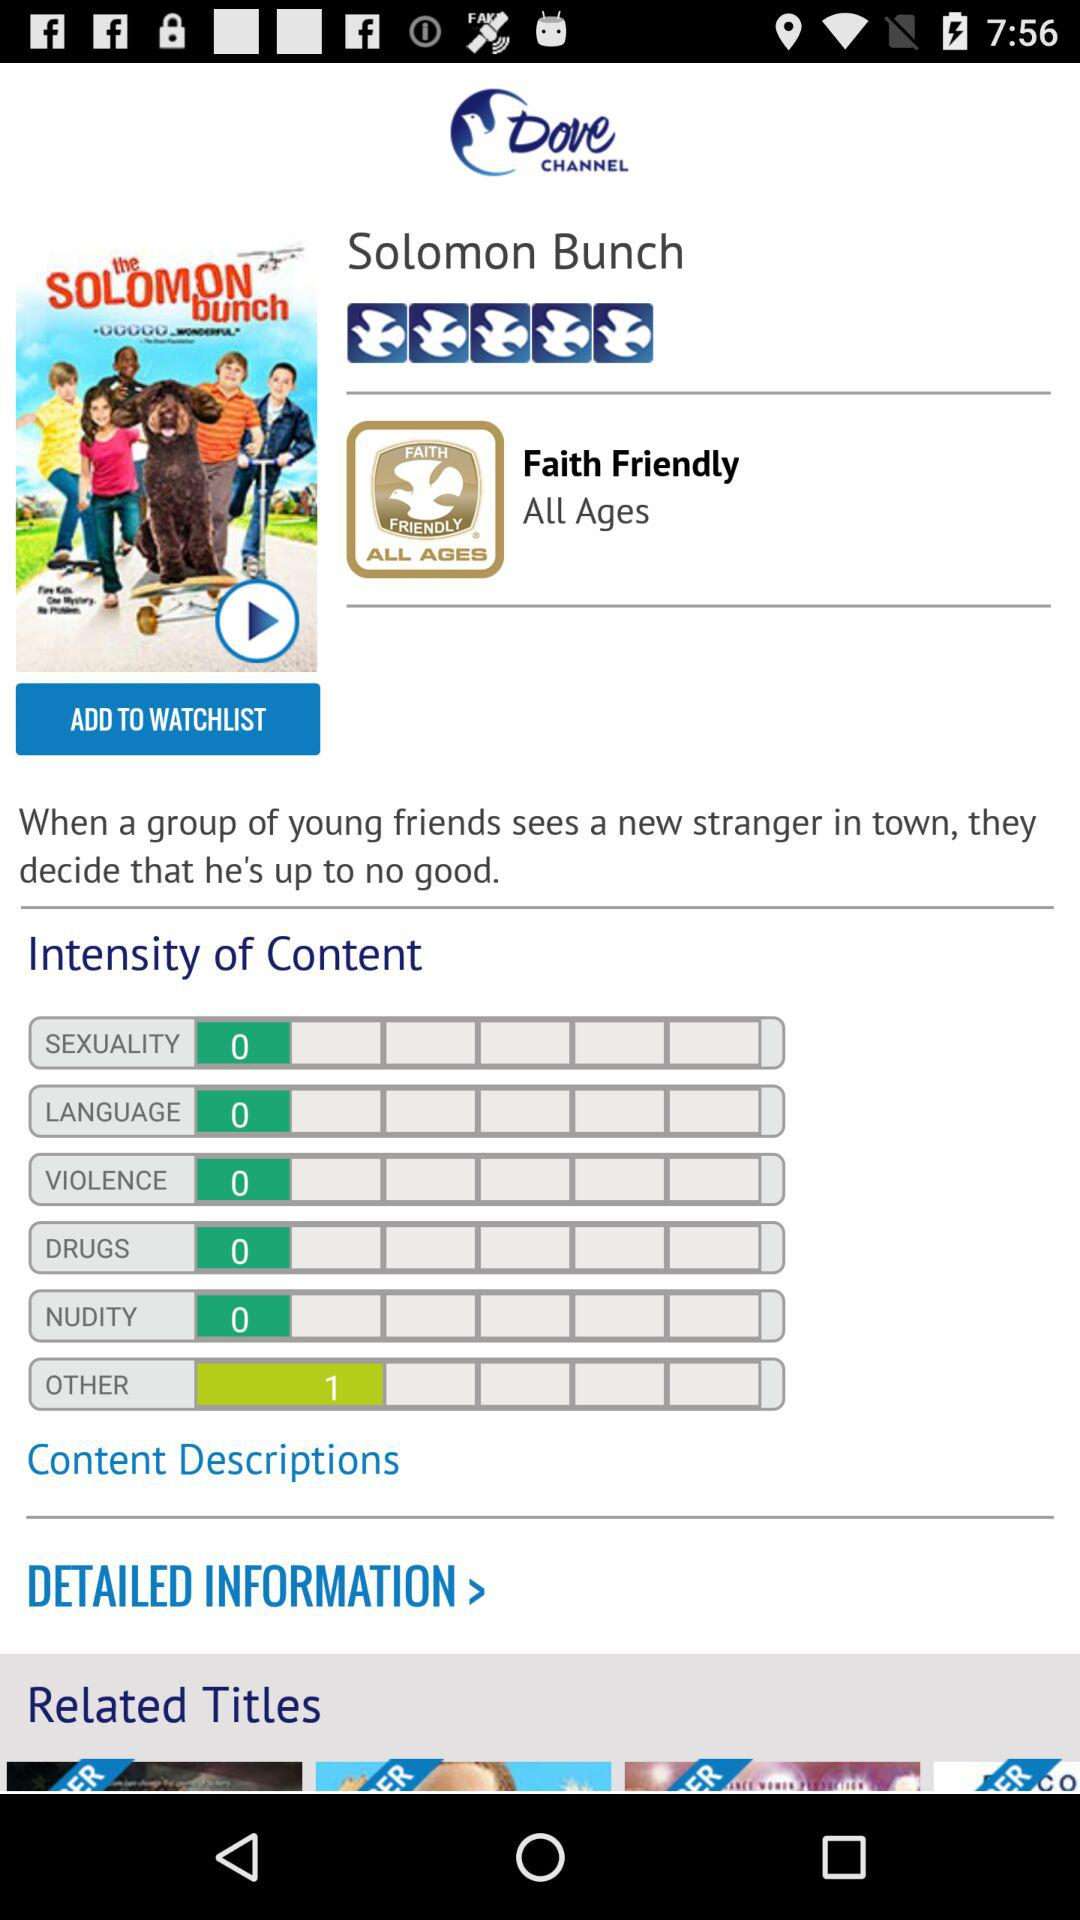What is the intensity of the violent content? The intensity of the violent content is 0. 